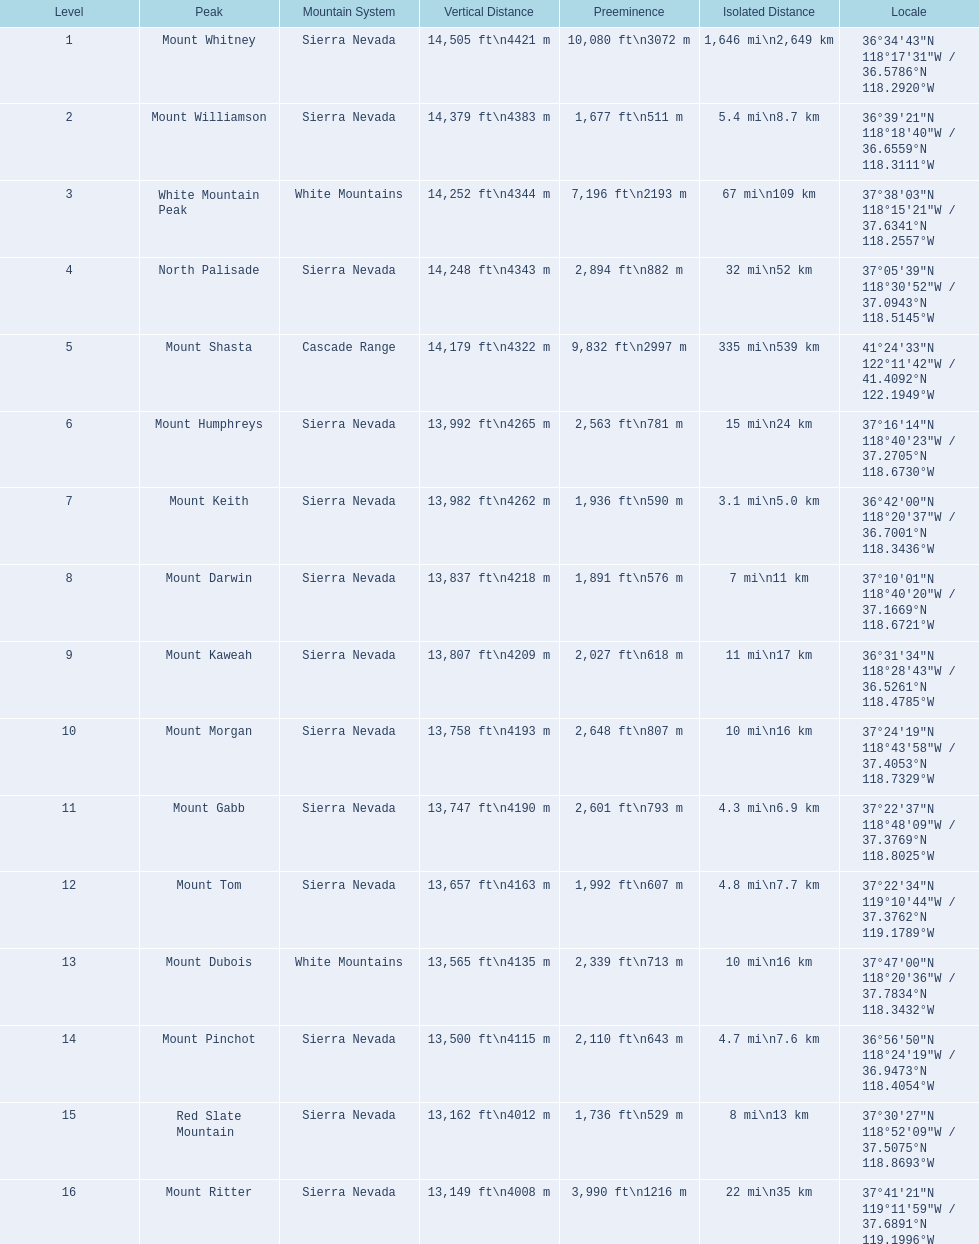Which mountain peak is in the white mountains range? White Mountain Peak. Which mountain is in the sierra nevada range? Mount Whitney. Which mountain is the only one in the cascade range? Mount Shasta. 